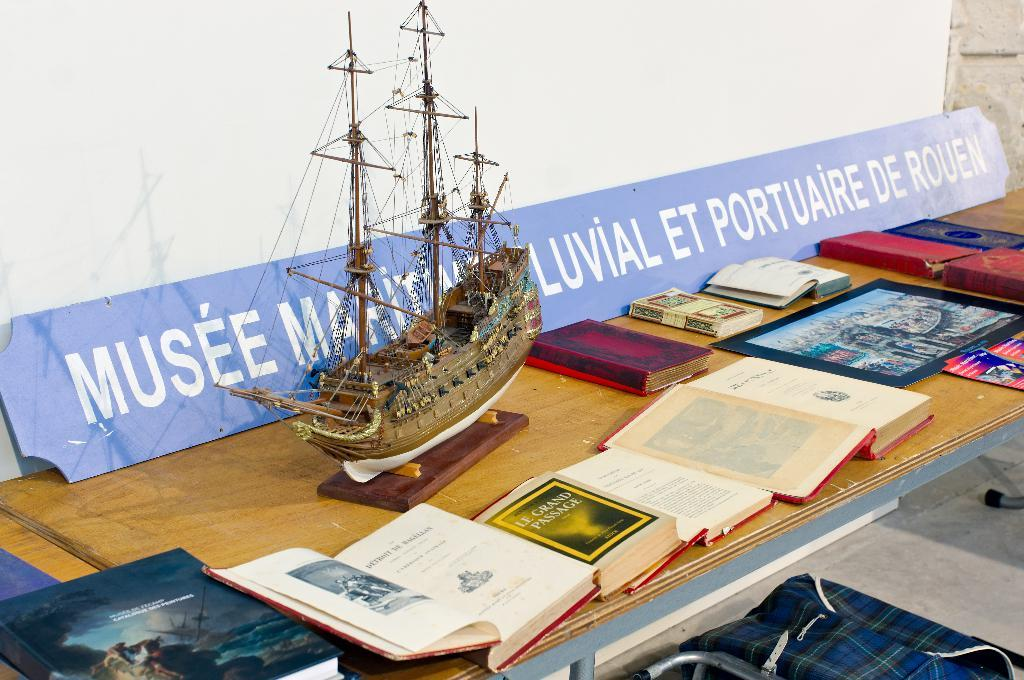<image>
Render a clear and concise summary of the photo. A table with a display of books and an old model ship and one book is called Le Grand Passage. 